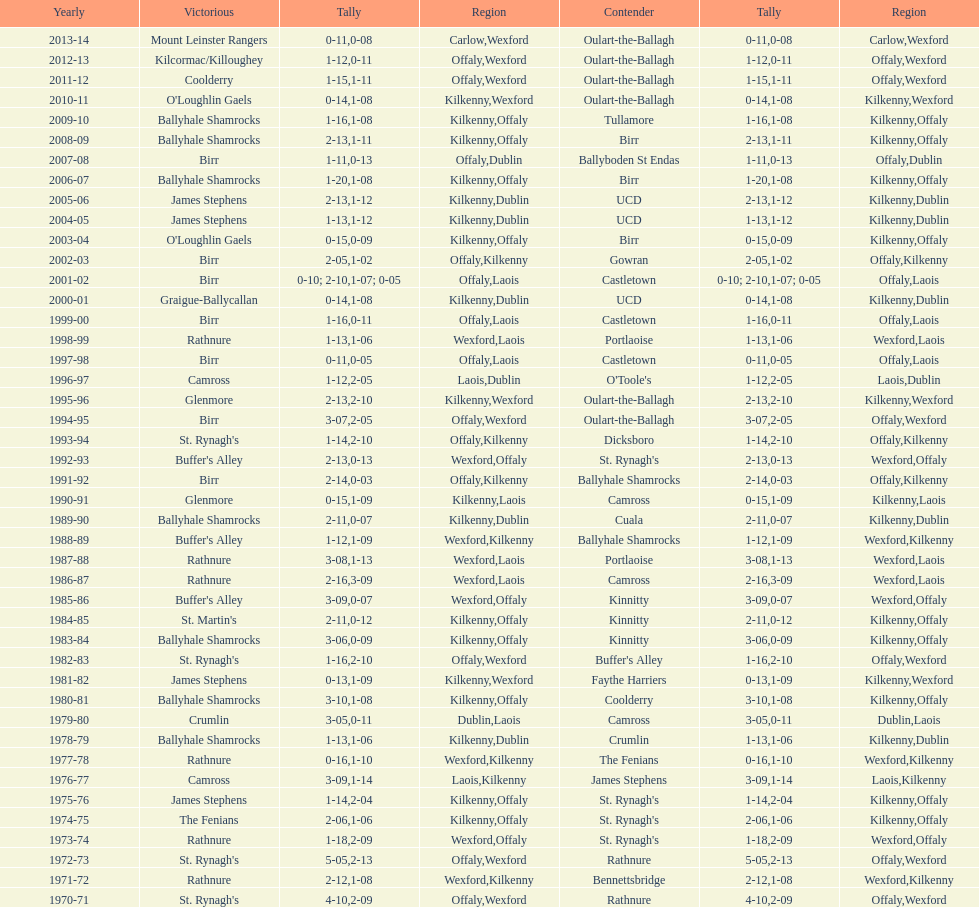In which most recent season was the leinster senior club hurling championships won with a score difference of under 11? 2007-08. 